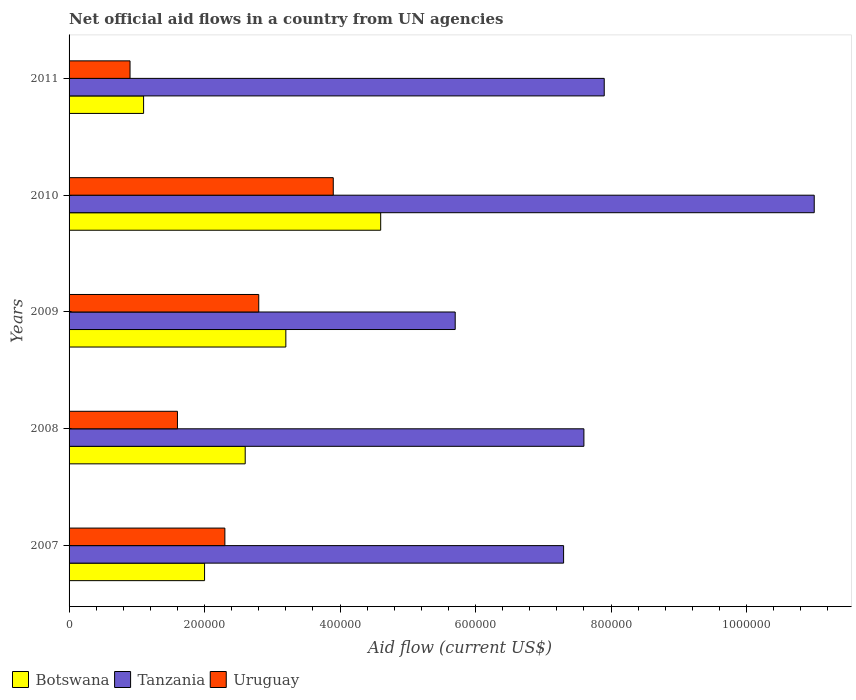How many groups of bars are there?
Your response must be concise. 5. How many bars are there on the 2nd tick from the top?
Your answer should be very brief. 3. What is the label of the 3rd group of bars from the top?
Your answer should be very brief. 2009. What is the net official aid flow in Tanzania in 2007?
Offer a very short reply. 7.30e+05. Across all years, what is the maximum net official aid flow in Botswana?
Make the answer very short. 4.60e+05. Across all years, what is the minimum net official aid flow in Tanzania?
Offer a very short reply. 5.70e+05. In which year was the net official aid flow in Uruguay minimum?
Offer a terse response. 2011. What is the total net official aid flow in Botswana in the graph?
Offer a terse response. 1.35e+06. What is the difference between the net official aid flow in Uruguay in 2008 and that in 2010?
Make the answer very short. -2.30e+05. What is the difference between the net official aid flow in Tanzania in 2011 and the net official aid flow in Uruguay in 2007?
Give a very brief answer. 5.60e+05. What is the average net official aid flow in Tanzania per year?
Provide a short and direct response. 7.90e+05. In the year 2010, what is the difference between the net official aid flow in Uruguay and net official aid flow in Tanzania?
Your response must be concise. -7.10e+05. What is the ratio of the net official aid flow in Uruguay in 2007 to that in 2010?
Offer a terse response. 0.59. Is the net official aid flow in Tanzania in 2009 less than that in 2011?
Ensure brevity in your answer.  Yes. What is the difference between the highest and the second highest net official aid flow in Uruguay?
Provide a short and direct response. 1.10e+05. What is the difference between the highest and the lowest net official aid flow in Tanzania?
Provide a short and direct response. 5.30e+05. In how many years, is the net official aid flow in Botswana greater than the average net official aid flow in Botswana taken over all years?
Make the answer very short. 2. What does the 3rd bar from the top in 2011 represents?
Make the answer very short. Botswana. What does the 3rd bar from the bottom in 2011 represents?
Your answer should be compact. Uruguay. Is it the case that in every year, the sum of the net official aid flow in Tanzania and net official aid flow in Uruguay is greater than the net official aid flow in Botswana?
Ensure brevity in your answer.  Yes. What is the difference between two consecutive major ticks on the X-axis?
Provide a succinct answer. 2.00e+05. Does the graph contain any zero values?
Offer a very short reply. No. Does the graph contain grids?
Provide a short and direct response. No. Where does the legend appear in the graph?
Provide a short and direct response. Bottom left. How many legend labels are there?
Make the answer very short. 3. What is the title of the graph?
Offer a terse response. Net official aid flows in a country from UN agencies. Does "Antigua and Barbuda" appear as one of the legend labels in the graph?
Keep it short and to the point. No. What is the label or title of the X-axis?
Give a very brief answer. Aid flow (current US$). What is the Aid flow (current US$) in Tanzania in 2007?
Provide a succinct answer. 7.30e+05. What is the Aid flow (current US$) of Botswana in 2008?
Your response must be concise. 2.60e+05. What is the Aid flow (current US$) of Tanzania in 2008?
Provide a short and direct response. 7.60e+05. What is the Aid flow (current US$) in Uruguay in 2008?
Give a very brief answer. 1.60e+05. What is the Aid flow (current US$) of Botswana in 2009?
Make the answer very short. 3.20e+05. What is the Aid flow (current US$) in Tanzania in 2009?
Ensure brevity in your answer.  5.70e+05. What is the Aid flow (current US$) of Botswana in 2010?
Offer a very short reply. 4.60e+05. What is the Aid flow (current US$) in Tanzania in 2010?
Provide a succinct answer. 1.10e+06. What is the Aid flow (current US$) in Uruguay in 2010?
Keep it short and to the point. 3.90e+05. What is the Aid flow (current US$) of Botswana in 2011?
Give a very brief answer. 1.10e+05. What is the Aid flow (current US$) in Tanzania in 2011?
Give a very brief answer. 7.90e+05. What is the Aid flow (current US$) of Uruguay in 2011?
Your answer should be compact. 9.00e+04. Across all years, what is the maximum Aid flow (current US$) of Botswana?
Your answer should be compact. 4.60e+05. Across all years, what is the maximum Aid flow (current US$) in Tanzania?
Offer a very short reply. 1.10e+06. Across all years, what is the minimum Aid flow (current US$) in Botswana?
Give a very brief answer. 1.10e+05. Across all years, what is the minimum Aid flow (current US$) in Tanzania?
Offer a very short reply. 5.70e+05. Across all years, what is the minimum Aid flow (current US$) of Uruguay?
Offer a terse response. 9.00e+04. What is the total Aid flow (current US$) in Botswana in the graph?
Provide a succinct answer. 1.35e+06. What is the total Aid flow (current US$) in Tanzania in the graph?
Offer a very short reply. 3.95e+06. What is the total Aid flow (current US$) of Uruguay in the graph?
Offer a very short reply. 1.15e+06. What is the difference between the Aid flow (current US$) of Botswana in 2007 and that in 2008?
Your answer should be compact. -6.00e+04. What is the difference between the Aid flow (current US$) of Tanzania in 2007 and that in 2008?
Your answer should be very brief. -3.00e+04. What is the difference between the Aid flow (current US$) in Uruguay in 2007 and that in 2008?
Keep it short and to the point. 7.00e+04. What is the difference between the Aid flow (current US$) of Botswana in 2007 and that in 2009?
Ensure brevity in your answer.  -1.20e+05. What is the difference between the Aid flow (current US$) in Uruguay in 2007 and that in 2009?
Your answer should be very brief. -5.00e+04. What is the difference between the Aid flow (current US$) in Tanzania in 2007 and that in 2010?
Give a very brief answer. -3.70e+05. What is the difference between the Aid flow (current US$) of Tanzania in 2007 and that in 2011?
Your answer should be compact. -6.00e+04. What is the difference between the Aid flow (current US$) of Botswana in 2008 and that in 2009?
Your answer should be very brief. -6.00e+04. What is the difference between the Aid flow (current US$) in Tanzania in 2008 and that in 2009?
Offer a terse response. 1.90e+05. What is the difference between the Aid flow (current US$) of Uruguay in 2008 and that in 2009?
Your answer should be very brief. -1.20e+05. What is the difference between the Aid flow (current US$) in Botswana in 2008 and that in 2010?
Make the answer very short. -2.00e+05. What is the difference between the Aid flow (current US$) in Tanzania in 2008 and that in 2010?
Keep it short and to the point. -3.40e+05. What is the difference between the Aid flow (current US$) of Botswana in 2008 and that in 2011?
Your response must be concise. 1.50e+05. What is the difference between the Aid flow (current US$) of Uruguay in 2008 and that in 2011?
Provide a succinct answer. 7.00e+04. What is the difference between the Aid flow (current US$) of Botswana in 2009 and that in 2010?
Keep it short and to the point. -1.40e+05. What is the difference between the Aid flow (current US$) in Tanzania in 2009 and that in 2010?
Ensure brevity in your answer.  -5.30e+05. What is the difference between the Aid flow (current US$) in Uruguay in 2009 and that in 2010?
Make the answer very short. -1.10e+05. What is the difference between the Aid flow (current US$) of Botswana in 2009 and that in 2011?
Provide a short and direct response. 2.10e+05. What is the difference between the Aid flow (current US$) of Uruguay in 2010 and that in 2011?
Your answer should be compact. 3.00e+05. What is the difference between the Aid flow (current US$) of Botswana in 2007 and the Aid flow (current US$) of Tanzania in 2008?
Your answer should be very brief. -5.60e+05. What is the difference between the Aid flow (current US$) of Tanzania in 2007 and the Aid flow (current US$) of Uruguay in 2008?
Your answer should be very brief. 5.70e+05. What is the difference between the Aid flow (current US$) in Botswana in 2007 and the Aid flow (current US$) in Tanzania in 2009?
Your response must be concise. -3.70e+05. What is the difference between the Aid flow (current US$) of Botswana in 2007 and the Aid flow (current US$) of Uruguay in 2009?
Your response must be concise. -8.00e+04. What is the difference between the Aid flow (current US$) of Botswana in 2007 and the Aid flow (current US$) of Tanzania in 2010?
Provide a short and direct response. -9.00e+05. What is the difference between the Aid flow (current US$) in Botswana in 2007 and the Aid flow (current US$) in Uruguay in 2010?
Your response must be concise. -1.90e+05. What is the difference between the Aid flow (current US$) in Botswana in 2007 and the Aid flow (current US$) in Tanzania in 2011?
Provide a succinct answer. -5.90e+05. What is the difference between the Aid flow (current US$) in Botswana in 2007 and the Aid flow (current US$) in Uruguay in 2011?
Keep it short and to the point. 1.10e+05. What is the difference between the Aid flow (current US$) in Tanzania in 2007 and the Aid flow (current US$) in Uruguay in 2011?
Make the answer very short. 6.40e+05. What is the difference between the Aid flow (current US$) in Botswana in 2008 and the Aid flow (current US$) in Tanzania in 2009?
Provide a succinct answer. -3.10e+05. What is the difference between the Aid flow (current US$) of Botswana in 2008 and the Aid flow (current US$) of Tanzania in 2010?
Give a very brief answer. -8.40e+05. What is the difference between the Aid flow (current US$) of Botswana in 2008 and the Aid flow (current US$) of Uruguay in 2010?
Ensure brevity in your answer.  -1.30e+05. What is the difference between the Aid flow (current US$) of Botswana in 2008 and the Aid flow (current US$) of Tanzania in 2011?
Give a very brief answer. -5.30e+05. What is the difference between the Aid flow (current US$) of Botswana in 2008 and the Aid flow (current US$) of Uruguay in 2011?
Your response must be concise. 1.70e+05. What is the difference between the Aid flow (current US$) in Tanzania in 2008 and the Aid flow (current US$) in Uruguay in 2011?
Offer a very short reply. 6.70e+05. What is the difference between the Aid flow (current US$) of Botswana in 2009 and the Aid flow (current US$) of Tanzania in 2010?
Offer a very short reply. -7.80e+05. What is the difference between the Aid flow (current US$) of Botswana in 2009 and the Aid flow (current US$) of Uruguay in 2010?
Provide a short and direct response. -7.00e+04. What is the difference between the Aid flow (current US$) in Tanzania in 2009 and the Aid flow (current US$) in Uruguay in 2010?
Offer a terse response. 1.80e+05. What is the difference between the Aid flow (current US$) of Botswana in 2009 and the Aid flow (current US$) of Tanzania in 2011?
Provide a short and direct response. -4.70e+05. What is the difference between the Aid flow (current US$) in Botswana in 2009 and the Aid flow (current US$) in Uruguay in 2011?
Make the answer very short. 2.30e+05. What is the difference between the Aid flow (current US$) of Botswana in 2010 and the Aid flow (current US$) of Tanzania in 2011?
Your answer should be compact. -3.30e+05. What is the difference between the Aid flow (current US$) in Botswana in 2010 and the Aid flow (current US$) in Uruguay in 2011?
Keep it short and to the point. 3.70e+05. What is the difference between the Aid flow (current US$) of Tanzania in 2010 and the Aid flow (current US$) of Uruguay in 2011?
Your answer should be compact. 1.01e+06. What is the average Aid flow (current US$) of Botswana per year?
Give a very brief answer. 2.70e+05. What is the average Aid flow (current US$) of Tanzania per year?
Your answer should be compact. 7.90e+05. In the year 2007, what is the difference between the Aid flow (current US$) in Botswana and Aid flow (current US$) in Tanzania?
Your answer should be very brief. -5.30e+05. In the year 2007, what is the difference between the Aid flow (current US$) of Tanzania and Aid flow (current US$) of Uruguay?
Provide a succinct answer. 5.00e+05. In the year 2008, what is the difference between the Aid flow (current US$) in Botswana and Aid flow (current US$) in Tanzania?
Provide a short and direct response. -5.00e+05. In the year 2010, what is the difference between the Aid flow (current US$) in Botswana and Aid flow (current US$) in Tanzania?
Your answer should be very brief. -6.40e+05. In the year 2010, what is the difference between the Aid flow (current US$) of Tanzania and Aid flow (current US$) of Uruguay?
Ensure brevity in your answer.  7.10e+05. In the year 2011, what is the difference between the Aid flow (current US$) of Botswana and Aid flow (current US$) of Tanzania?
Give a very brief answer. -6.80e+05. In the year 2011, what is the difference between the Aid flow (current US$) of Tanzania and Aid flow (current US$) of Uruguay?
Offer a terse response. 7.00e+05. What is the ratio of the Aid flow (current US$) of Botswana in 2007 to that in 2008?
Offer a terse response. 0.77. What is the ratio of the Aid flow (current US$) of Tanzania in 2007 to that in 2008?
Your answer should be compact. 0.96. What is the ratio of the Aid flow (current US$) in Uruguay in 2007 to that in 2008?
Provide a short and direct response. 1.44. What is the ratio of the Aid flow (current US$) of Tanzania in 2007 to that in 2009?
Provide a short and direct response. 1.28. What is the ratio of the Aid flow (current US$) of Uruguay in 2007 to that in 2009?
Your answer should be compact. 0.82. What is the ratio of the Aid flow (current US$) in Botswana in 2007 to that in 2010?
Ensure brevity in your answer.  0.43. What is the ratio of the Aid flow (current US$) of Tanzania in 2007 to that in 2010?
Your answer should be very brief. 0.66. What is the ratio of the Aid flow (current US$) of Uruguay in 2007 to that in 2010?
Ensure brevity in your answer.  0.59. What is the ratio of the Aid flow (current US$) of Botswana in 2007 to that in 2011?
Your response must be concise. 1.82. What is the ratio of the Aid flow (current US$) in Tanzania in 2007 to that in 2011?
Ensure brevity in your answer.  0.92. What is the ratio of the Aid flow (current US$) of Uruguay in 2007 to that in 2011?
Offer a very short reply. 2.56. What is the ratio of the Aid flow (current US$) of Botswana in 2008 to that in 2009?
Offer a terse response. 0.81. What is the ratio of the Aid flow (current US$) of Uruguay in 2008 to that in 2009?
Your answer should be compact. 0.57. What is the ratio of the Aid flow (current US$) of Botswana in 2008 to that in 2010?
Give a very brief answer. 0.57. What is the ratio of the Aid flow (current US$) of Tanzania in 2008 to that in 2010?
Make the answer very short. 0.69. What is the ratio of the Aid flow (current US$) in Uruguay in 2008 to that in 2010?
Your answer should be compact. 0.41. What is the ratio of the Aid flow (current US$) in Botswana in 2008 to that in 2011?
Give a very brief answer. 2.36. What is the ratio of the Aid flow (current US$) of Uruguay in 2008 to that in 2011?
Give a very brief answer. 1.78. What is the ratio of the Aid flow (current US$) of Botswana in 2009 to that in 2010?
Offer a very short reply. 0.7. What is the ratio of the Aid flow (current US$) of Tanzania in 2009 to that in 2010?
Your answer should be compact. 0.52. What is the ratio of the Aid flow (current US$) in Uruguay in 2009 to that in 2010?
Your answer should be compact. 0.72. What is the ratio of the Aid flow (current US$) in Botswana in 2009 to that in 2011?
Offer a very short reply. 2.91. What is the ratio of the Aid flow (current US$) of Tanzania in 2009 to that in 2011?
Offer a terse response. 0.72. What is the ratio of the Aid flow (current US$) in Uruguay in 2009 to that in 2011?
Offer a very short reply. 3.11. What is the ratio of the Aid flow (current US$) in Botswana in 2010 to that in 2011?
Provide a short and direct response. 4.18. What is the ratio of the Aid flow (current US$) of Tanzania in 2010 to that in 2011?
Your response must be concise. 1.39. What is the ratio of the Aid flow (current US$) in Uruguay in 2010 to that in 2011?
Provide a short and direct response. 4.33. What is the difference between the highest and the second highest Aid flow (current US$) in Botswana?
Your answer should be very brief. 1.40e+05. What is the difference between the highest and the second highest Aid flow (current US$) of Tanzania?
Offer a terse response. 3.10e+05. What is the difference between the highest and the lowest Aid flow (current US$) in Botswana?
Offer a very short reply. 3.50e+05. What is the difference between the highest and the lowest Aid flow (current US$) in Tanzania?
Offer a very short reply. 5.30e+05. What is the difference between the highest and the lowest Aid flow (current US$) in Uruguay?
Offer a very short reply. 3.00e+05. 